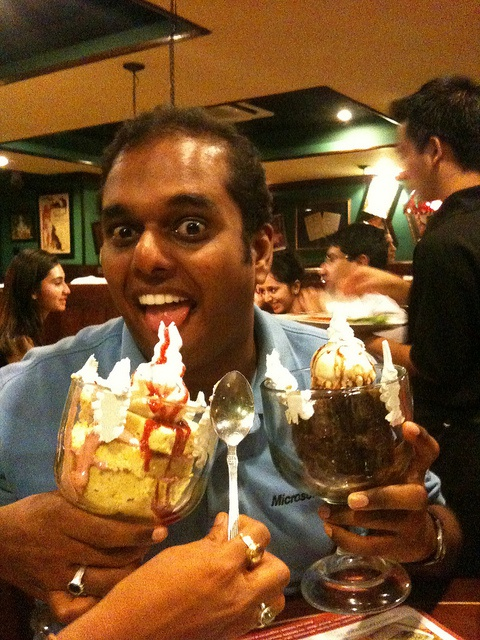Describe the objects in this image and their specific colors. I can see people in olive, maroon, black, brown, and gray tones, people in olive, black, brown, maroon, and red tones, cake in olive, ivory, orange, and red tones, people in olive, red, brown, orange, and maroon tones, and dining table in olive, maroon, black, and brown tones in this image. 